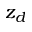<formula> <loc_0><loc_0><loc_500><loc_500>z _ { d }</formula> 